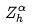Convert formula to latex. <formula><loc_0><loc_0><loc_500><loc_500>Z _ { h } ^ { \alpha }</formula> 